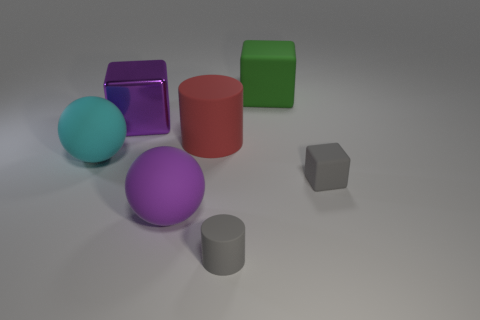What number of big purple balls are the same material as the green cube?
Offer a very short reply. 1. There is a matte cube behind the matte block that is in front of the green thing; what color is it?
Your answer should be very brief. Green. How many objects are big green matte blocks or rubber objects in front of the big green block?
Your response must be concise. 6. Is there a metallic block of the same color as the small matte cylinder?
Keep it short and to the point. No. How many purple objects are matte cylinders or large cylinders?
Give a very brief answer. 0. What number of other things are there of the same size as the gray cube?
Your response must be concise. 1. How many large things are either purple things or gray metal spheres?
Keep it short and to the point. 2. Does the red object have the same size as the purple thing that is behind the purple ball?
Your response must be concise. Yes. What number of other objects are the same shape as the purple matte thing?
Provide a succinct answer. 1. There is a large red object that is made of the same material as the green block; what shape is it?
Your answer should be very brief. Cylinder. 